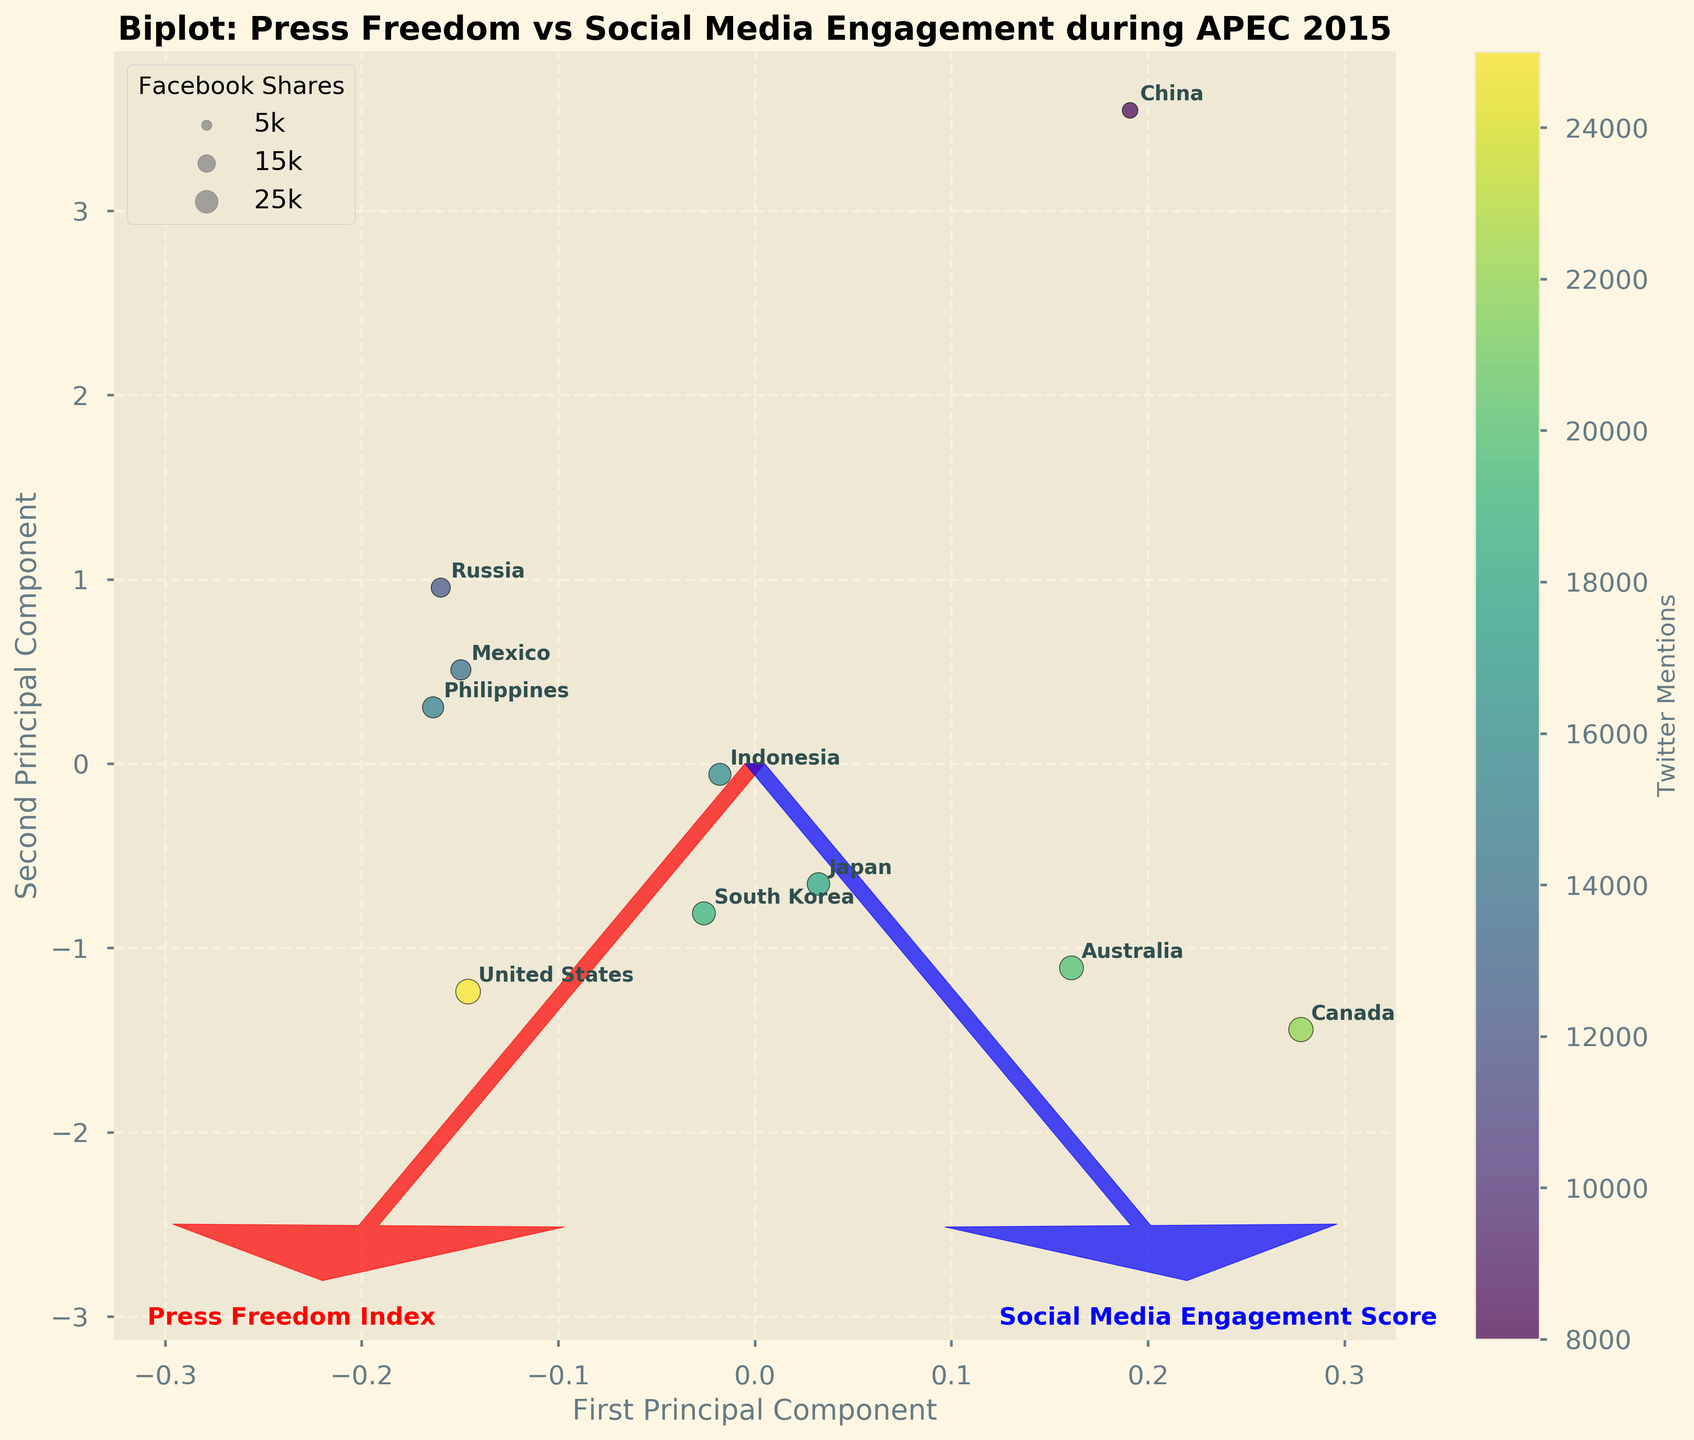What is the title of the figure? The title of the figure is displayed at the top and reads "Biplot: Press Freedom vs Social Media Engagement during APEC 2015"
Answer: Biplot: Press Freedom vs Social Media Engagement during APEC 2015 How is Twitter Mentions represented in the plot? The figure uses color to denote Twitter Mentions, with varying shades on a viridis color scale to indicate different levels of mentions. The color bar on the side of the plot labels these levels.
Answer: By color Which country has the highest Twitter Mentions? The color of the country with the darkest shade of color on the viridis scale indicates the highest Twitter Mentions. The United States, with the darkest shade, is thus the country with the highest number of Twitter Mentions.
Answer: United States How are Facebook Shares represented in the plot? Facebook Shares are depicted by the size of the bubbles, with larger bubbles indicating higher shares. The legend indicates the size association.
Answer: By bubble size Which country has the smallest value for the Press Freedom Index? Observing the arrow marked "Press Freedom Index," we note the country closest or along the negative direction of the Press Freedom Index's eigenvector. Canada is positioned closest to that point, indicating the smallest Press Freedom Index.
Answer: Canada Is there a general trend between Press Freedom Index and Social Media Engagement Score? By examining the directions of the eigenvectors for both variables and their positions in relation to each other, one can discern that countries with lower Press Freedom Index don't consistently align with a specific Social Media Engagement Score.
Answer: No consistent trend Which of the countries has the highest Social Media Engagement Score? Following the labeled "Social Media Engagement Score" arrow, the country furthest in that direction would indicate the highest score. The United States is the furthest in that direction, indicating the highest score.
Answer: United States How do Australia and Russia compare in terms of Facebook Shares? By comparing the size of the bubbles representing both countries, it is evident that Australia's bubble is larger than Russia's, indicating Australia has more Facebook Shares.
Answer: Australia has more Which country shows a balance between high Social Media Engagement and moderate Press Freedom? Finding a point that lies neither in the extreme of both Principal Components but still in a favorable range would be necessary. The projection for Indonesia appears to balance both aspects effectively.
Answer: Indonesia 